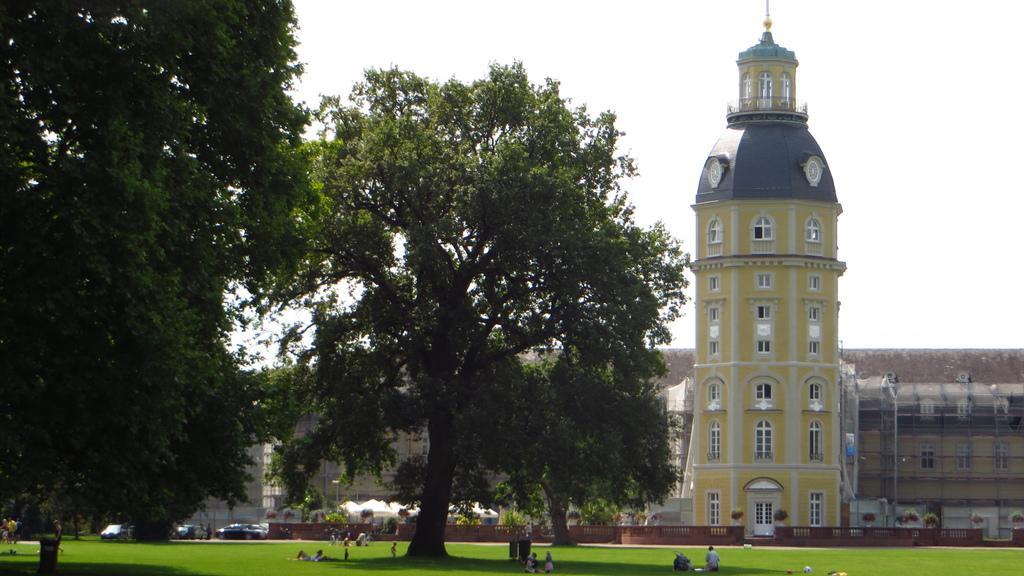In one or two sentences, can you explain what this image depicts? In this image in the left there are trees. There are few people on the ground. In the background there are buildings. On the road there are vehicles. There are plants and trees in the background. 